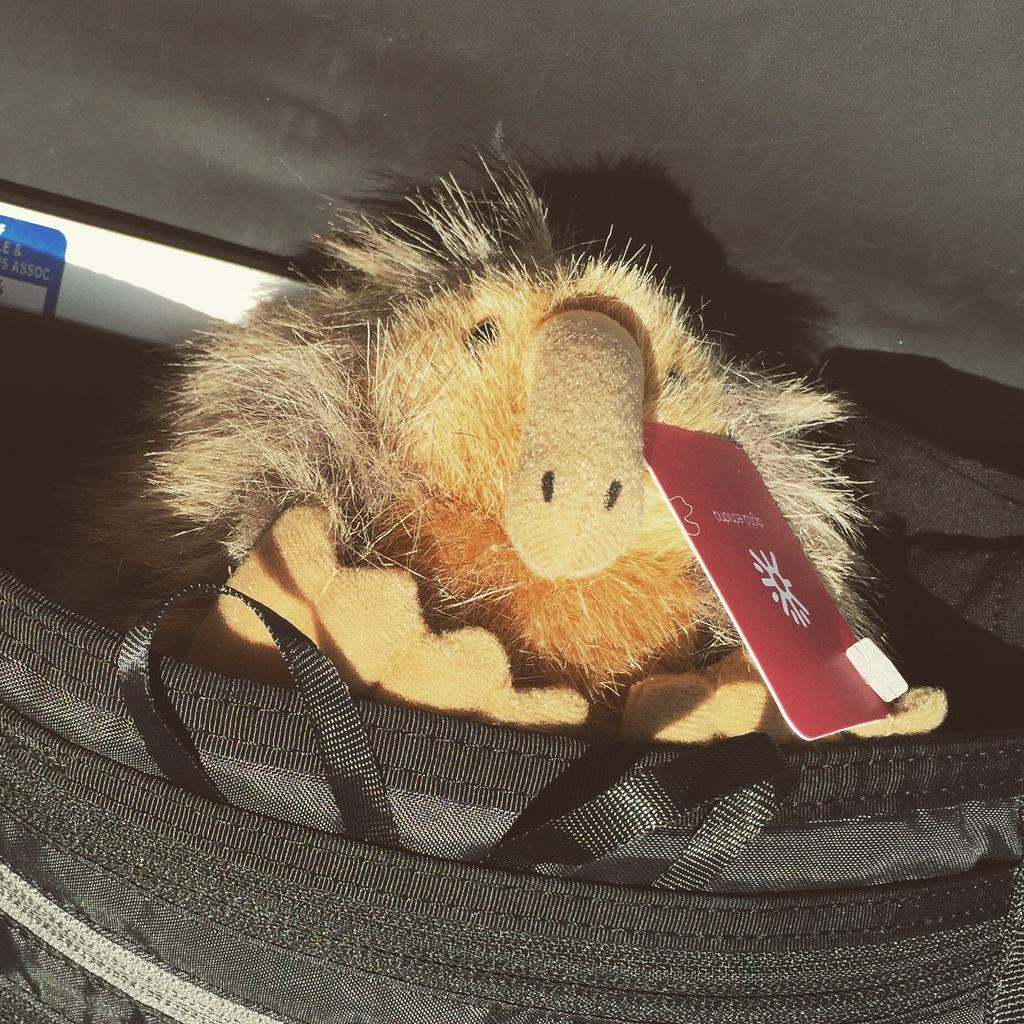What is the main object in the image? There is a toy with a tag in the image. Where is the toy located? The toy is in a bag. What can be seen in the background of the image? There is a sticker on a board in the background of the image. How many pigs are visible in the image? There are no pigs present in the image. What type of door is featured in the image? There is no door present in the image. 